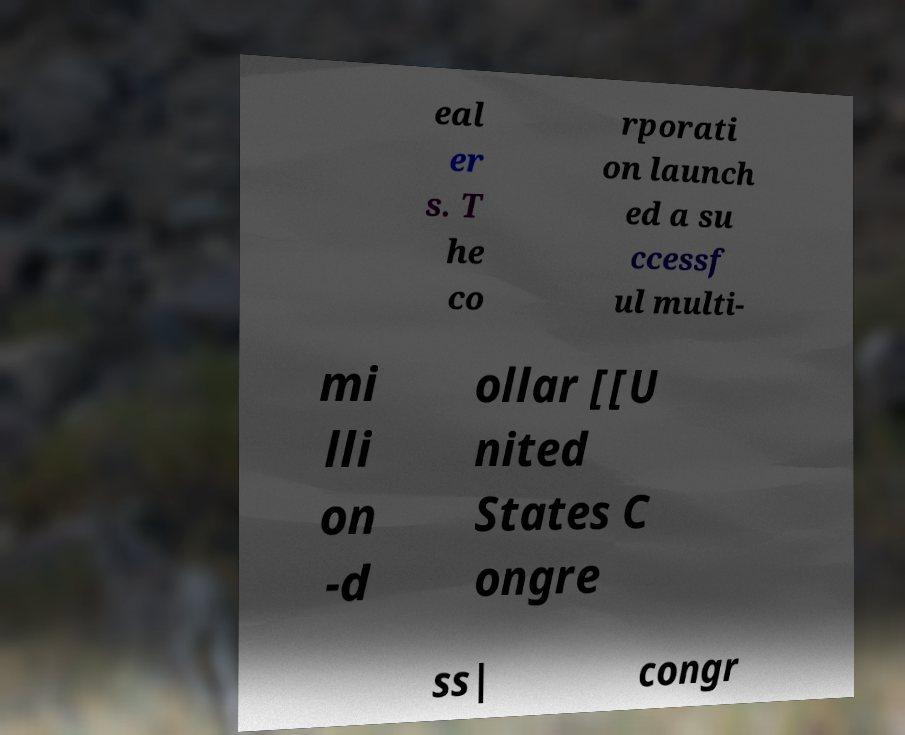Please identify and transcribe the text found in this image. eal er s. T he co rporati on launch ed a su ccessf ul multi- mi lli on -d ollar [[U nited States C ongre ss| congr 